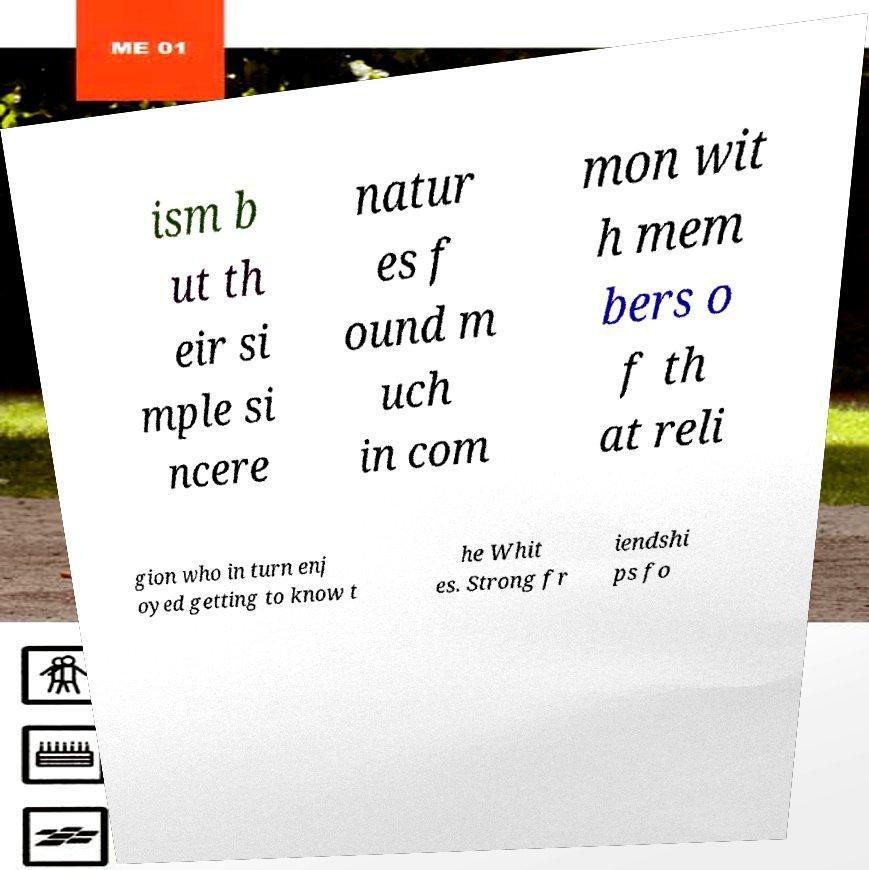Please identify and transcribe the text found in this image. ism b ut th eir si mple si ncere natur es f ound m uch in com mon wit h mem bers o f th at reli gion who in turn enj oyed getting to know t he Whit es. Strong fr iendshi ps fo 